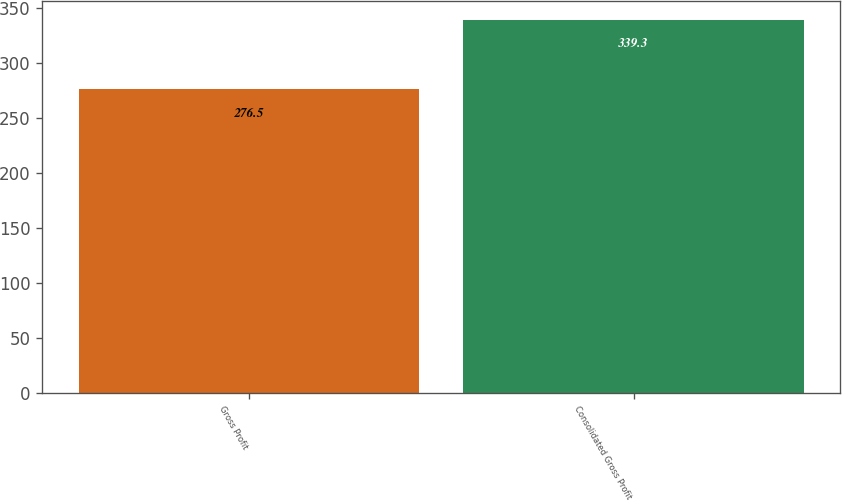<chart> <loc_0><loc_0><loc_500><loc_500><bar_chart><fcel>Gross Profit<fcel>Consolidated Gross Profit<nl><fcel>276.5<fcel>339.3<nl></chart> 